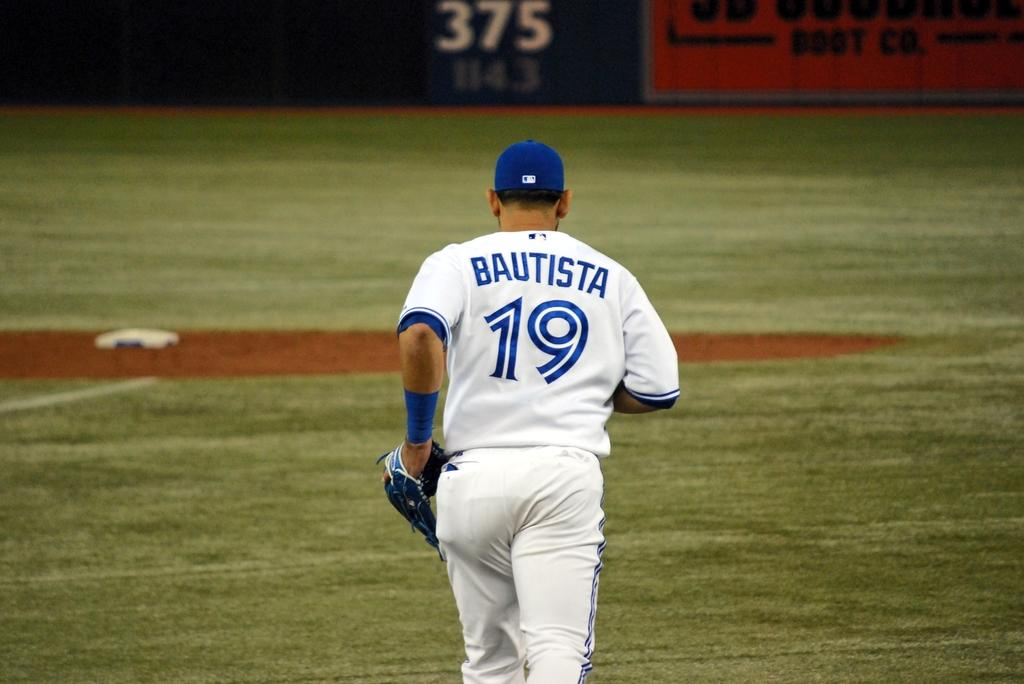<image>
Present a compact description of the photo's key features. The baseball player is on the field with BAUTISTA on the back of his uniform and # 19. 